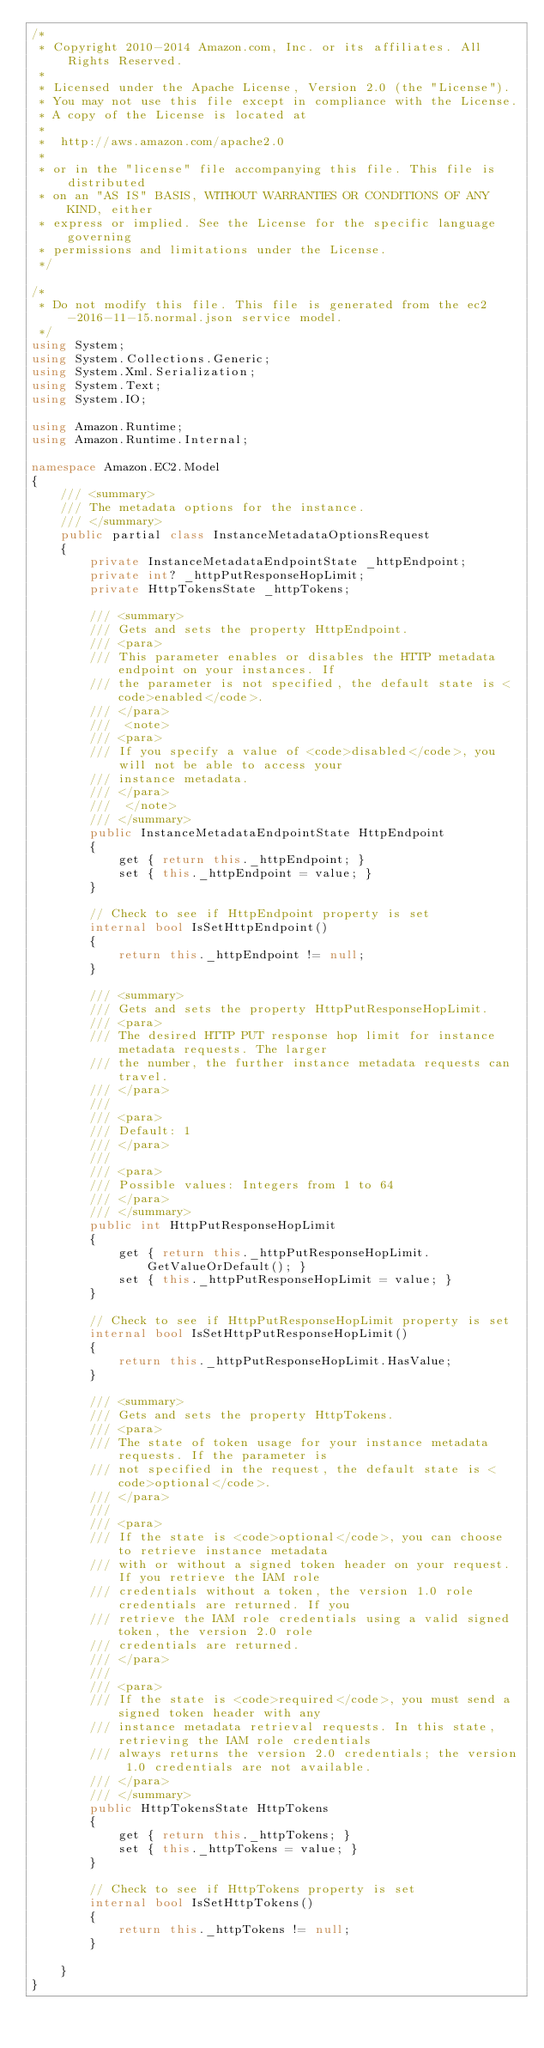Convert code to text. <code><loc_0><loc_0><loc_500><loc_500><_C#_>/*
 * Copyright 2010-2014 Amazon.com, Inc. or its affiliates. All Rights Reserved.
 * 
 * Licensed under the Apache License, Version 2.0 (the "License").
 * You may not use this file except in compliance with the License.
 * A copy of the License is located at
 * 
 *  http://aws.amazon.com/apache2.0
 * 
 * or in the "license" file accompanying this file. This file is distributed
 * on an "AS IS" BASIS, WITHOUT WARRANTIES OR CONDITIONS OF ANY KIND, either
 * express or implied. See the License for the specific language governing
 * permissions and limitations under the License.
 */

/*
 * Do not modify this file. This file is generated from the ec2-2016-11-15.normal.json service model.
 */
using System;
using System.Collections.Generic;
using System.Xml.Serialization;
using System.Text;
using System.IO;

using Amazon.Runtime;
using Amazon.Runtime.Internal;

namespace Amazon.EC2.Model
{
    /// <summary>
    /// The metadata options for the instance.
    /// </summary>
    public partial class InstanceMetadataOptionsRequest
    {
        private InstanceMetadataEndpointState _httpEndpoint;
        private int? _httpPutResponseHopLimit;
        private HttpTokensState _httpTokens;

        /// <summary>
        /// Gets and sets the property HttpEndpoint. 
        /// <para>
        /// This parameter enables or disables the HTTP metadata endpoint on your instances. If
        /// the parameter is not specified, the default state is <code>enabled</code>.
        /// </para>
        ///  <note> 
        /// <para>
        /// If you specify a value of <code>disabled</code>, you will not be able to access your
        /// instance metadata.
        /// </para>
        ///  </note>
        /// </summary>
        public InstanceMetadataEndpointState HttpEndpoint
        {
            get { return this._httpEndpoint; }
            set { this._httpEndpoint = value; }
        }

        // Check to see if HttpEndpoint property is set
        internal bool IsSetHttpEndpoint()
        {
            return this._httpEndpoint != null;
        }

        /// <summary>
        /// Gets and sets the property HttpPutResponseHopLimit. 
        /// <para>
        /// The desired HTTP PUT response hop limit for instance metadata requests. The larger
        /// the number, the further instance metadata requests can travel.
        /// </para>
        ///  
        /// <para>
        /// Default: 1
        /// </para>
        ///  
        /// <para>
        /// Possible values: Integers from 1 to 64
        /// </para>
        /// </summary>
        public int HttpPutResponseHopLimit
        {
            get { return this._httpPutResponseHopLimit.GetValueOrDefault(); }
            set { this._httpPutResponseHopLimit = value; }
        }

        // Check to see if HttpPutResponseHopLimit property is set
        internal bool IsSetHttpPutResponseHopLimit()
        {
            return this._httpPutResponseHopLimit.HasValue; 
        }

        /// <summary>
        /// Gets and sets the property HttpTokens. 
        /// <para>
        /// The state of token usage for your instance metadata requests. If the parameter is
        /// not specified in the request, the default state is <code>optional</code>.
        /// </para>
        ///  
        /// <para>
        /// If the state is <code>optional</code>, you can choose to retrieve instance metadata
        /// with or without a signed token header on your request. If you retrieve the IAM role
        /// credentials without a token, the version 1.0 role credentials are returned. If you
        /// retrieve the IAM role credentials using a valid signed token, the version 2.0 role
        /// credentials are returned.
        /// </para>
        ///  
        /// <para>
        /// If the state is <code>required</code>, you must send a signed token header with any
        /// instance metadata retrieval requests. In this state, retrieving the IAM role credentials
        /// always returns the version 2.0 credentials; the version 1.0 credentials are not available.
        /// </para>
        /// </summary>
        public HttpTokensState HttpTokens
        {
            get { return this._httpTokens; }
            set { this._httpTokens = value; }
        }

        // Check to see if HttpTokens property is set
        internal bool IsSetHttpTokens()
        {
            return this._httpTokens != null;
        }

    }
}</code> 